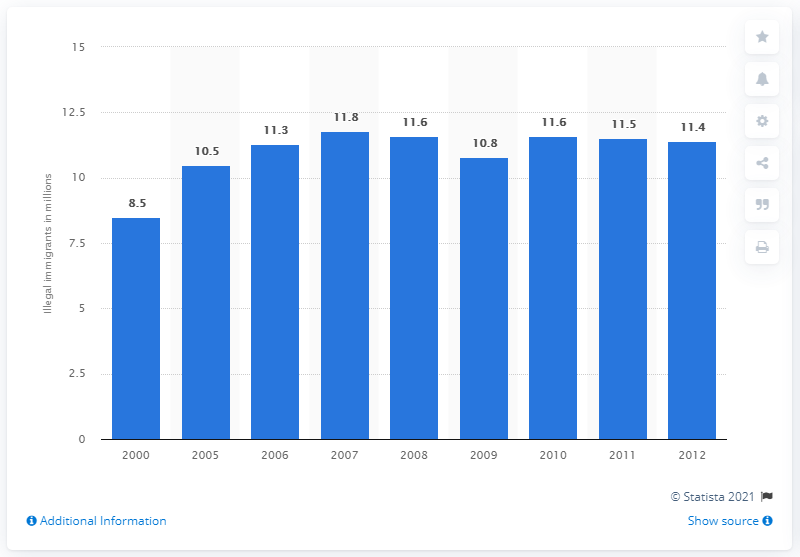Point out several critical features in this image. In 2012, it is estimated that approximately 11.3 million illegal immigrants were residing in the United States. 